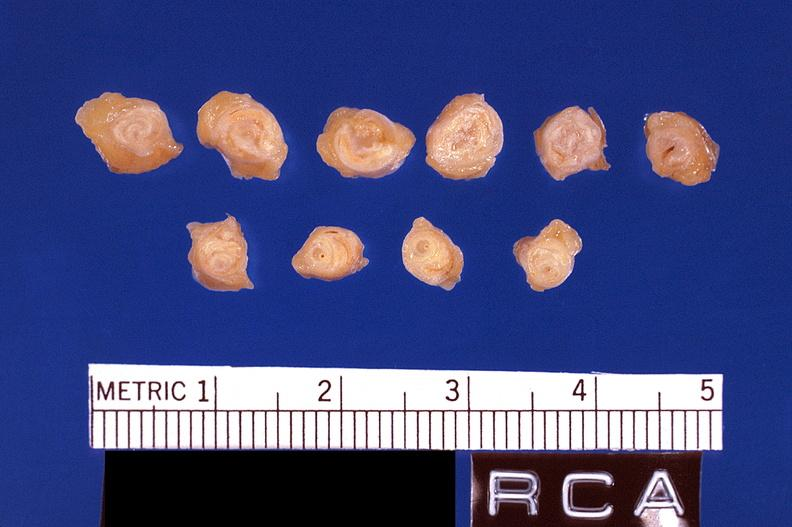what does this image show?
Answer the question using a single word or phrase. Atherosclerosis 